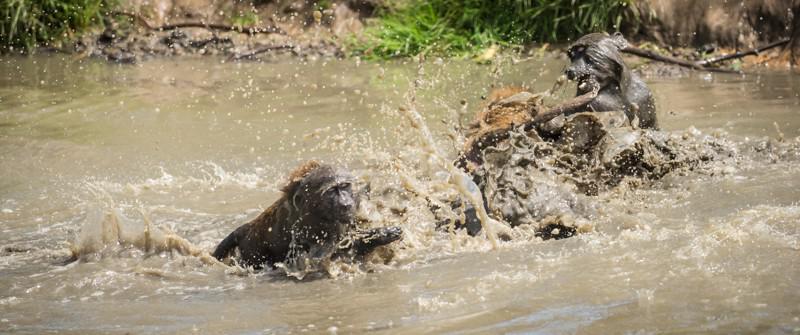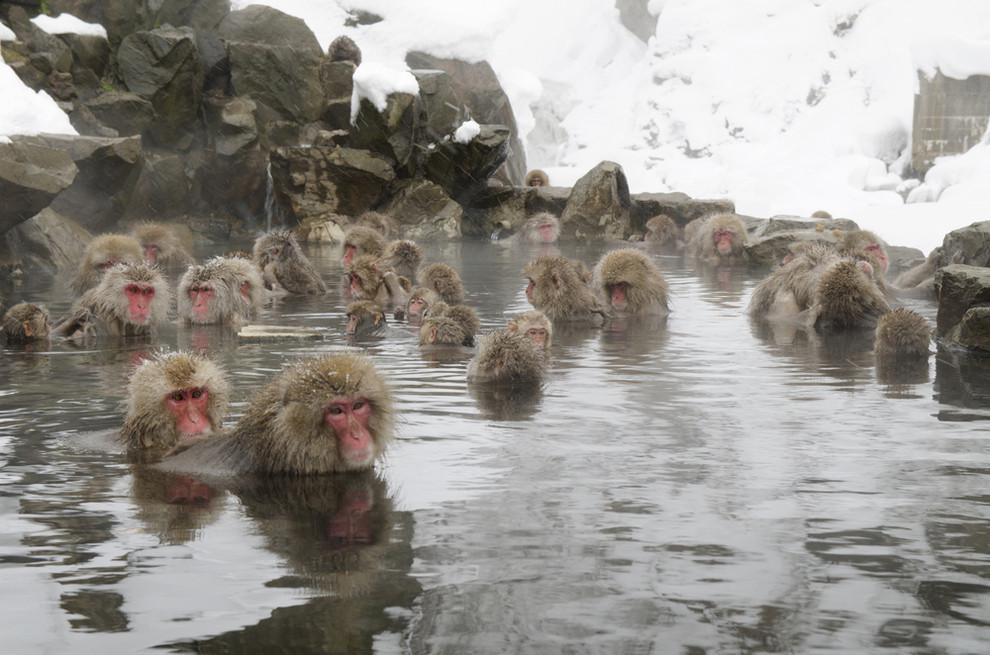The first image is the image on the left, the second image is the image on the right. Evaluate the accuracy of this statement regarding the images: "Both images show multiple monkeys in pools of water.". Is it true? Answer yes or no. Yes. 